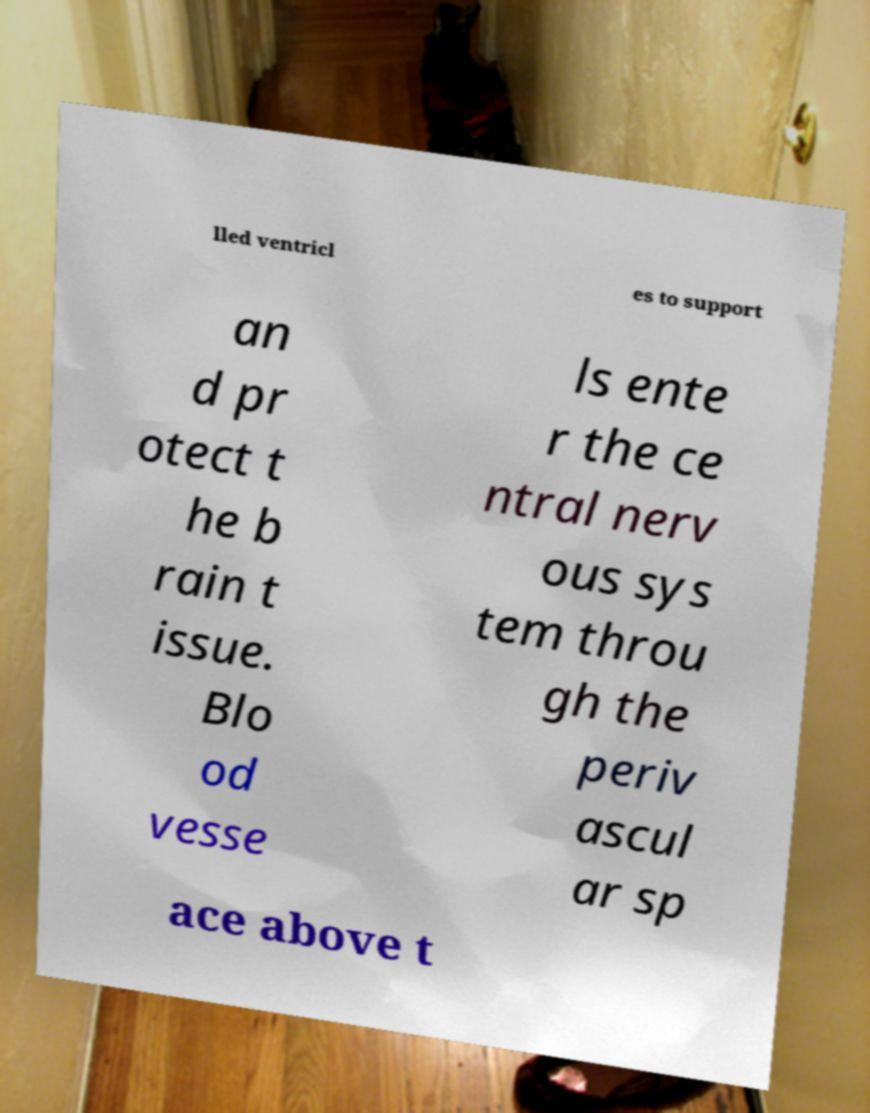Could you assist in decoding the text presented in this image and type it out clearly? lled ventricl es to support an d pr otect t he b rain t issue. Blo od vesse ls ente r the ce ntral nerv ous sys tem throu gh the periv ascul ar sp ace above t 